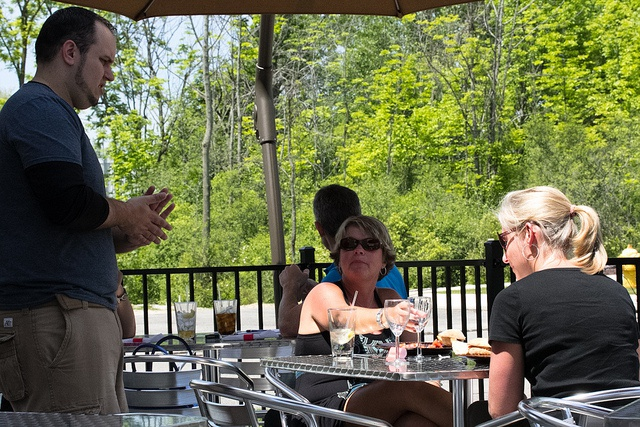Describe the objects in this image and their specific colors. I can see people in lightgray, black, and gray tones, people in lightgray, black, ivory, gray, and tan tones, people in lightgray, black, maroon, and brown tones, umbrella in lightgray, black, gray, and darkgreen tones, and dining table in lightgray, gray, darkgray, and black tones in this image. 